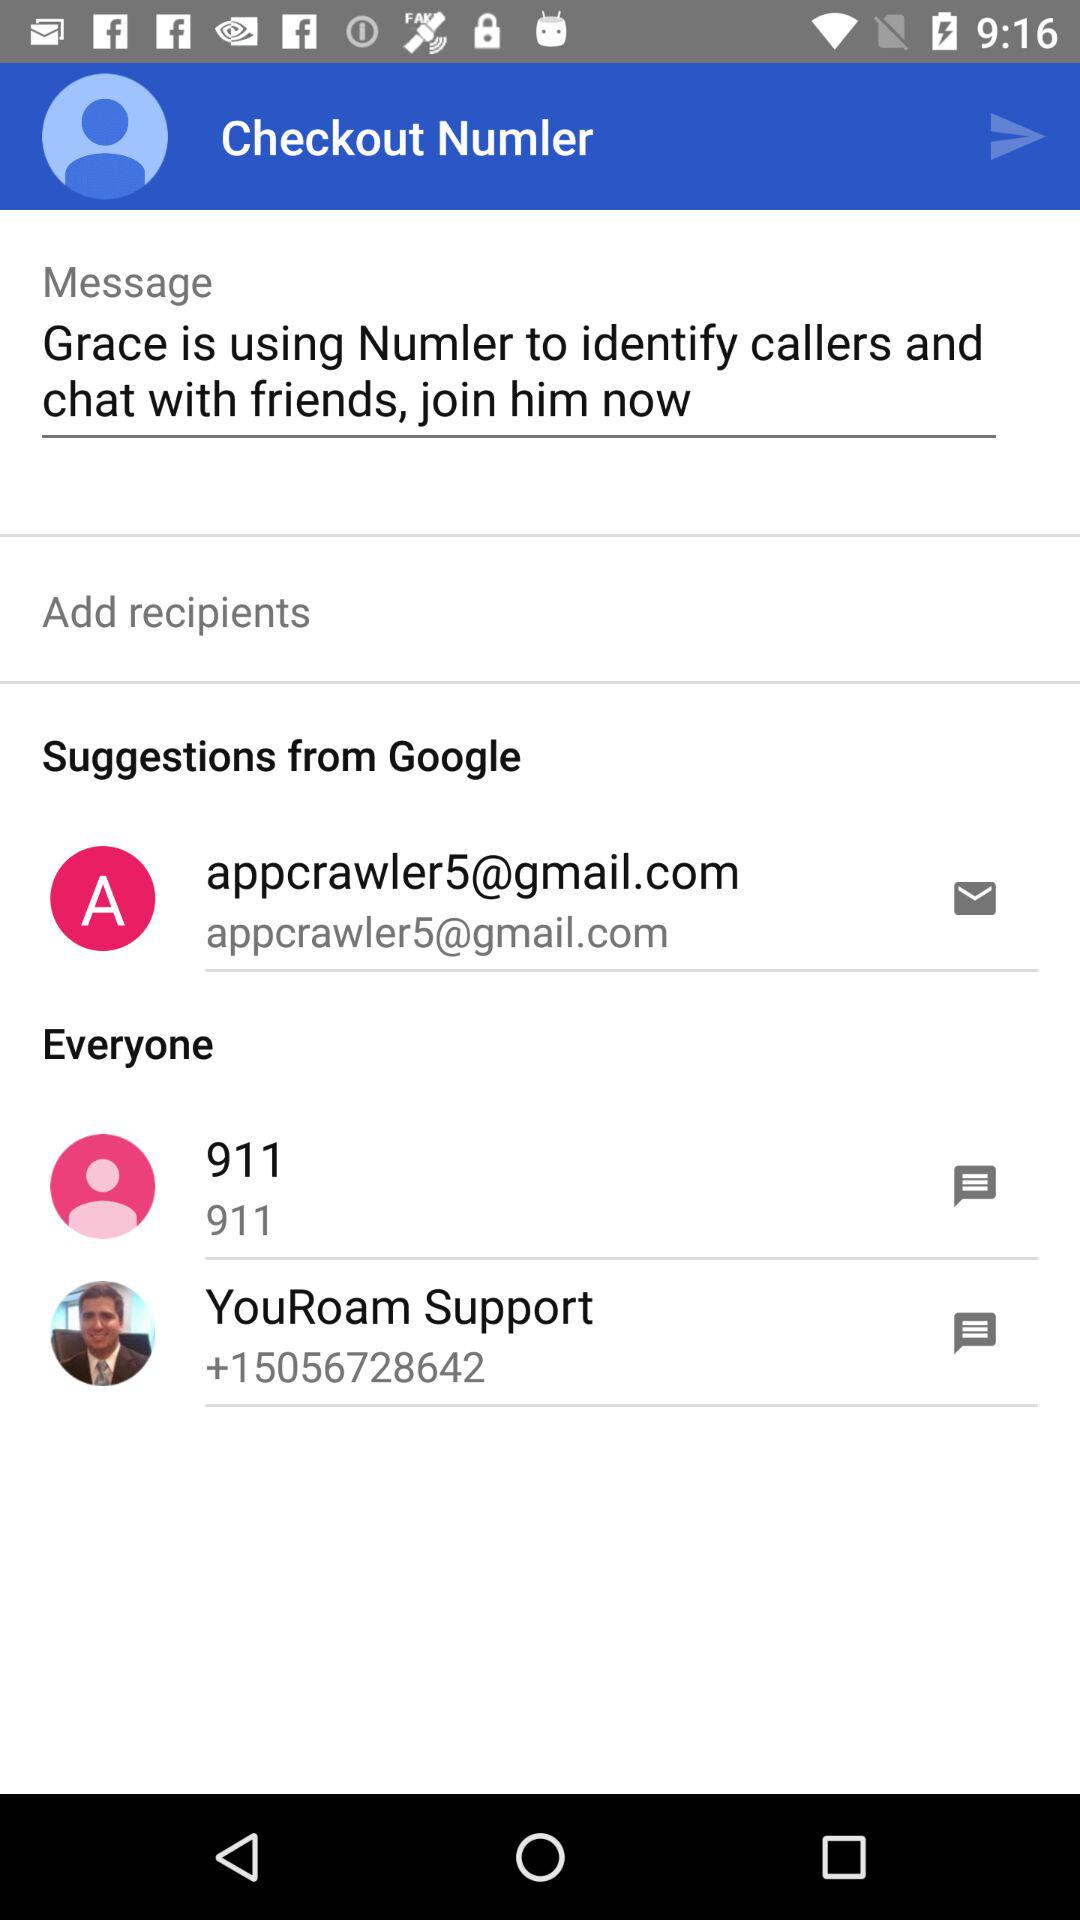What is the email address? The email address is appcrawler5@gmail.com. 